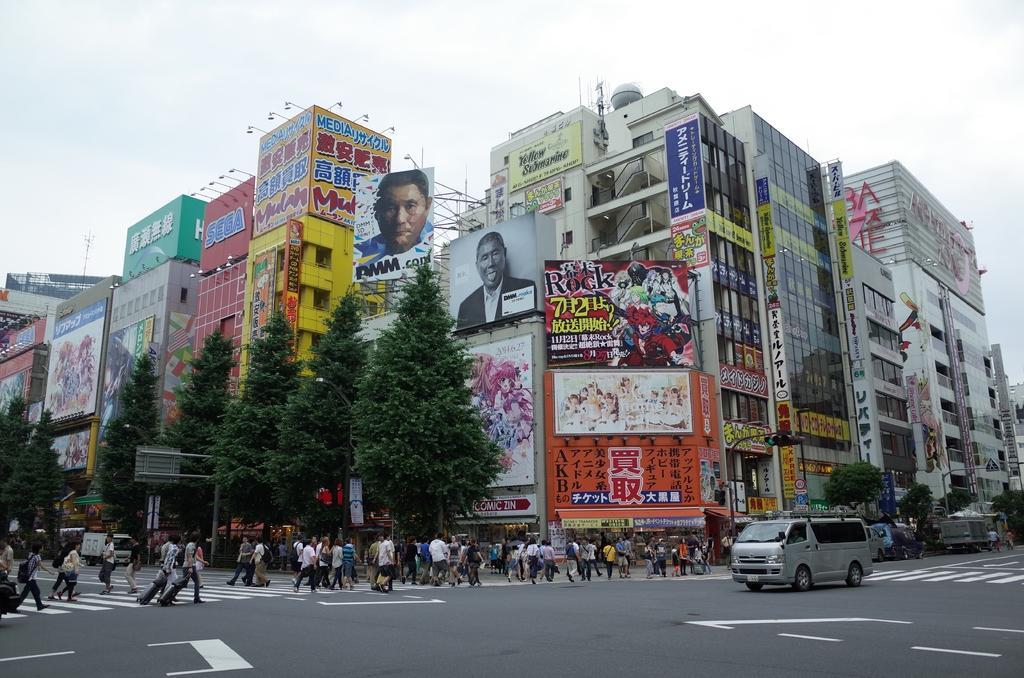Please provide a concise description of this image. In the center of the picture there are buildings, hoardings and trees. In the foreground of the picture it is road, on the road there are people and vehicles. sky is cloudy. On the right there are trees, vehicles and a street light. 